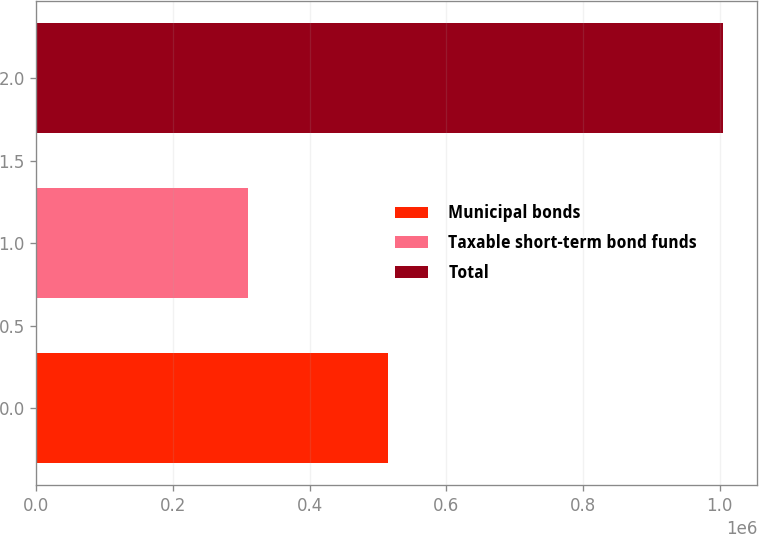<chart> <loc_0><loc_0><loc_500><loc_500><bar_chart><fcel>Municipal bonds<fcel>Taxable short-term bond funds<fcel>Total<nl><fcel>514330<fcel>309972<fcel>1.00433e+06<nl></chart> 